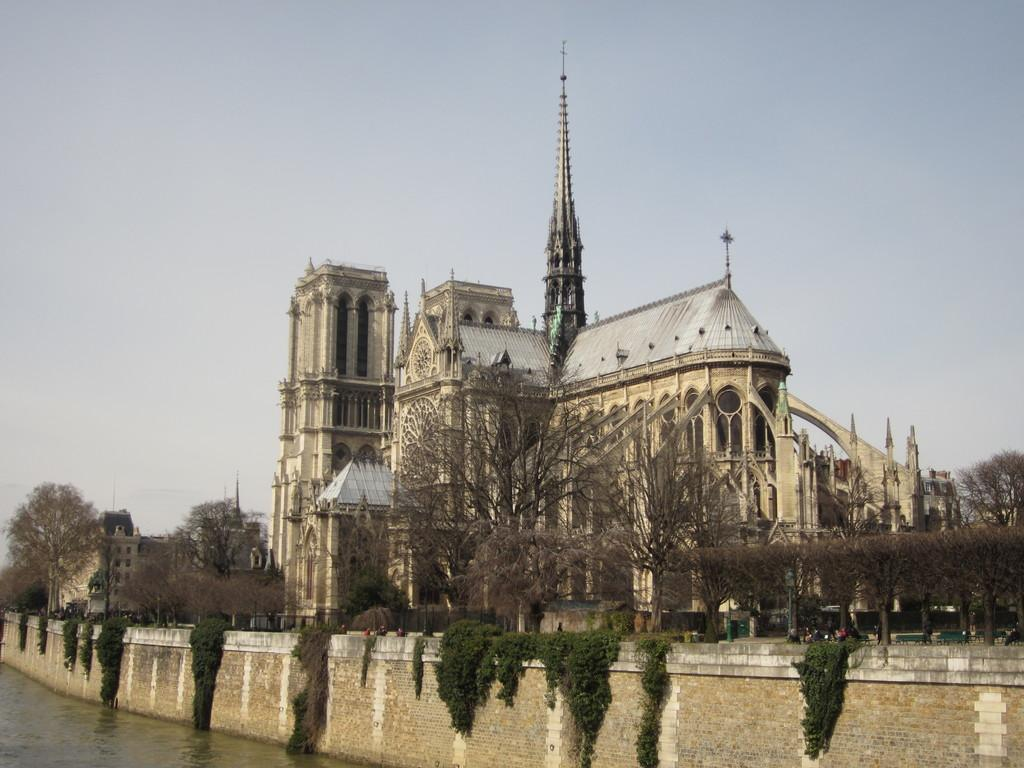What is located on the left side of the wall in the image? There is water on the left side of the wall in the image. What can be seen behind the wall? Trees and buildings are visible behind the wall. What is visible in the sky in the image? The sky is visible in the image. What type of ear is being used for teaching in the image? There is no ear or teaching activity present in the image. 